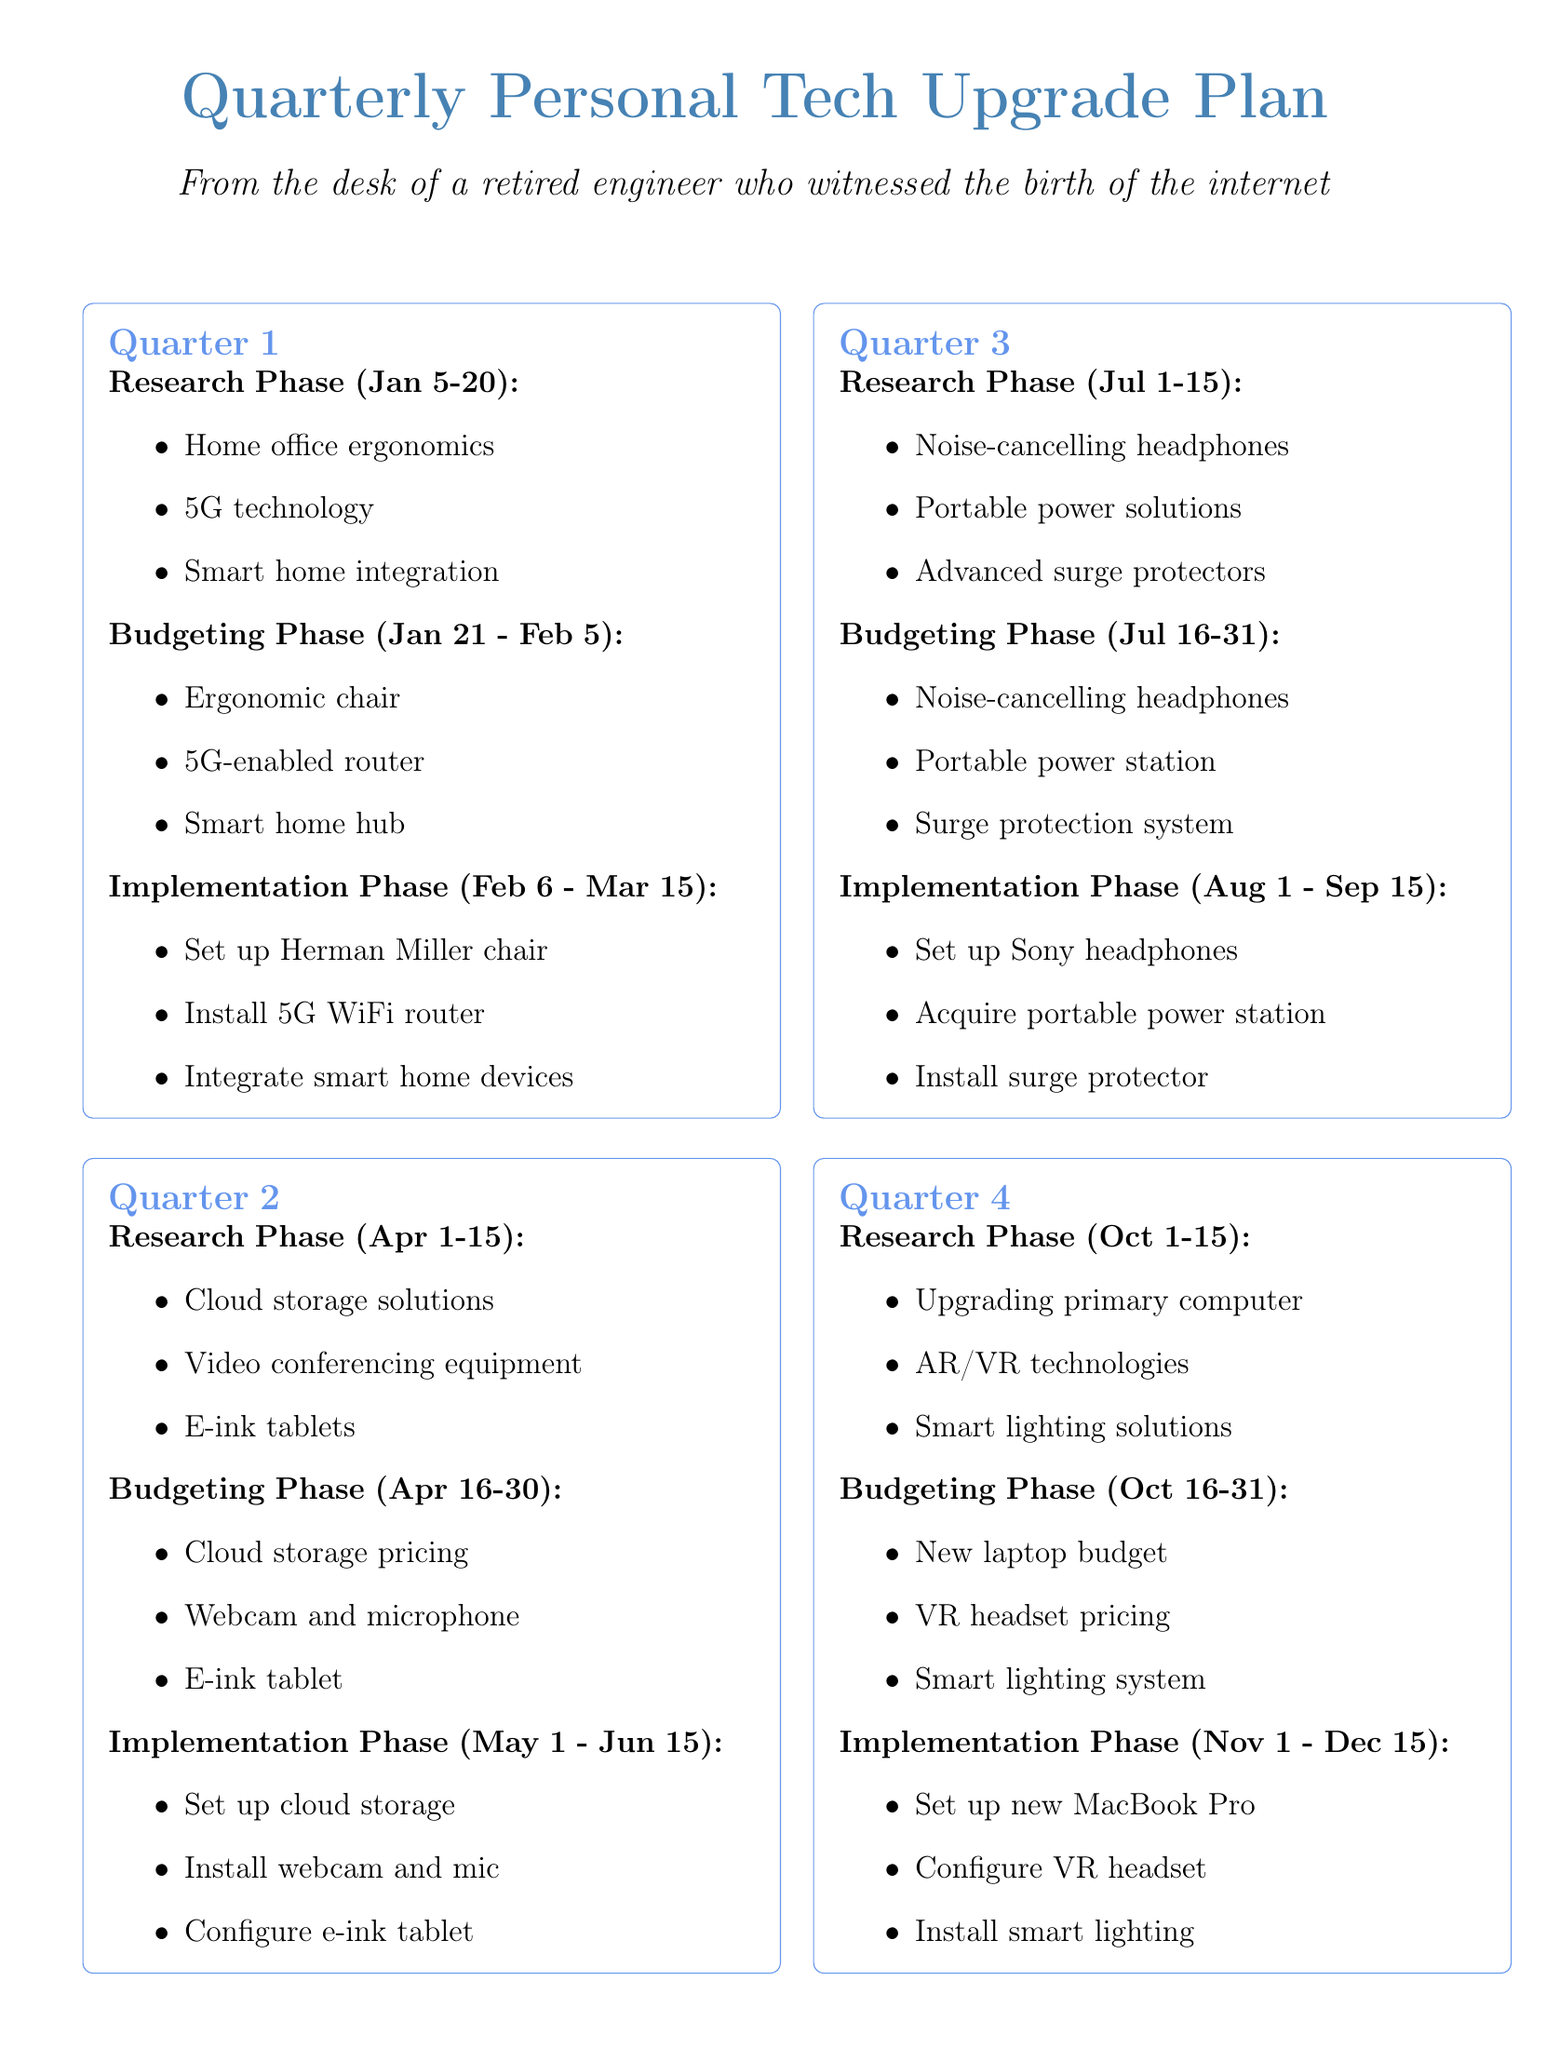What is the duration of the research phase in Q1? The research phase in Q1 lasts from January 5 to January 20, which is a total of 15 days.
Answer: 15 days What are the focus areas for Q3 research? The focus areas for Q3 include noise-cancelling headphones, portable power solutions, and advanced surge protectors.
Answer: Noise-cancelling headphones, portable power solutions, advanced surge protectors What is the budget consideration for Q2? Budget considerations in Q2 include comparing pricing for cloud storage providers, allocating funds for video conferencing equipment, and budgeting for an e-ink tablet.
Answer: Cloud storage pricing, video conferencing equipment, e-ink tablet When does the budgeting phase for Q4 start? The budgeting phase for Q4 starts on October 16 and ends on October 31.
Answer: October 16 What task is associated with the implementation phase in Q1? In Q1, tasks in the implementation phase include setting up the Herman Miller Aeron chair and installing the 5G router.
Answer: Set up Herman Miller Aeron chair, install 5G router How many weeks does the implementation phase for Q2 last? The implementation phase for Q2 lasts from May 1 to June 15, which is approximately 6 weeks.
Answer: 6 weeks What is the total number of phases in each quarter? Each quarter consists of three phases: research, budgeting, and implementation.
Answer: Three phases Which month does the research phase for Q4 begin? The research phase for Q4 begins in October, specifically on October 1.
Answer: October What technology is planned for integration in Q1? The planned technology integration in Q1 includes the Amazon Echo Show 15 with existing smart home devices.
Answer: Amazon Echo Show 15 